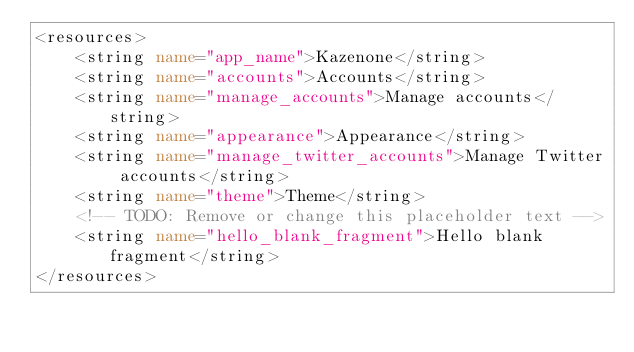<code> <loc_0><loc_0><loc_500><loc_500><_XML_><resources>
    <string name="app_name">Kazenone</string>
    <string name="accounts">Accounts</string>
    <string name="manage_accounts">Manage accounts</string>
    <string name="appearance">Appearance</string>
    <string name="manage_twitter_accounts">Manage Twitter accounts</string>
    <string name="theme">Theme</string>
    <!-- TODO: Remove or change this placeholder text -->
    <string name="hello_blank_fragment">Hello blank fragment</string>
</resources></code> 